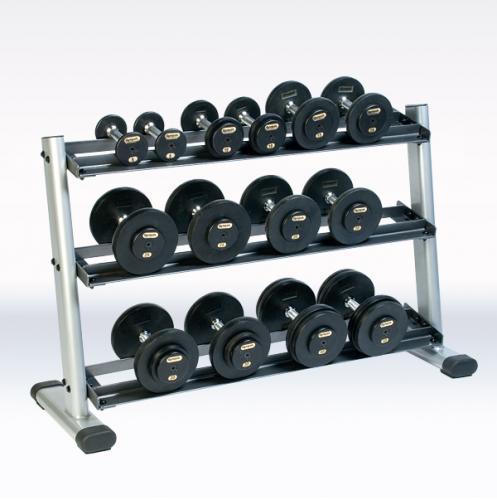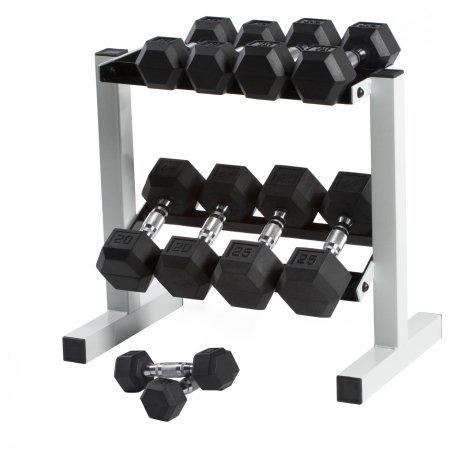The first image is the image on the left, the second image is the image on the right. Considering the images on both sides, is "One image shows a weight rack that holds three rows of dumbbells with hexagon-shaped ends." valid? Answer yes or no. No. 